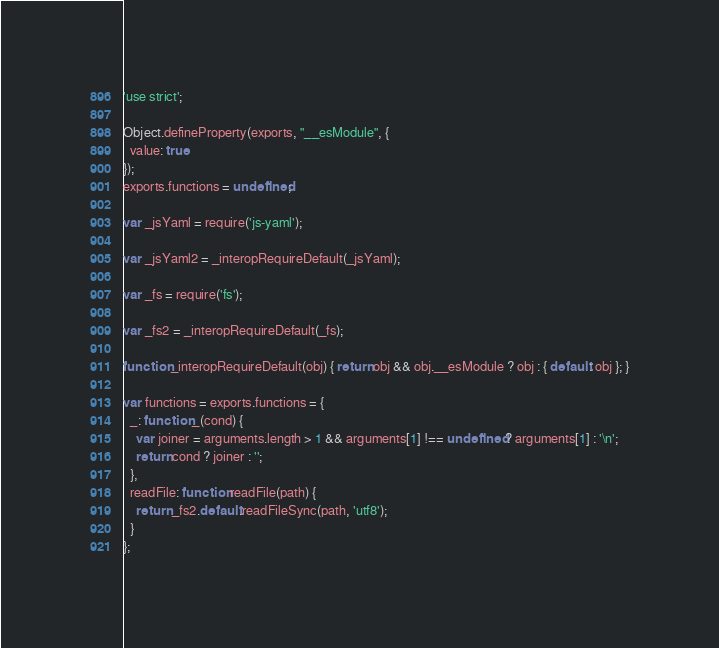Convert code to text. <code><loc_0><loc_0><loc_500><loc_500><_JavaScript_>'use strict';

Object.defineProperty(exports, "__esModule", {
  value: true
});
exports.functions = undefined;

var _jsYaml = require('js-yaml');

var _jsYaml2 = _interopRequireDefault(_jsYaml);

var _fs = require('fs');

var _fs2 = _interopRequireDefault(_fs);

function _interopRequireDefault(obj) { return obj && obj.__esModule ? obj : { default: obj }; }

var functions = exports.functions = {
  _: function _(cond) {
    var joiner = arguments.length > 1 && arguments[1] !== undefined ? arguments[1] : '\n';
    return cond ? joiner : '';
  },
  readFile: function readFile(path) {
    return _fs2.default.readFileSync(path, 'utf8');
  }
};</code> 